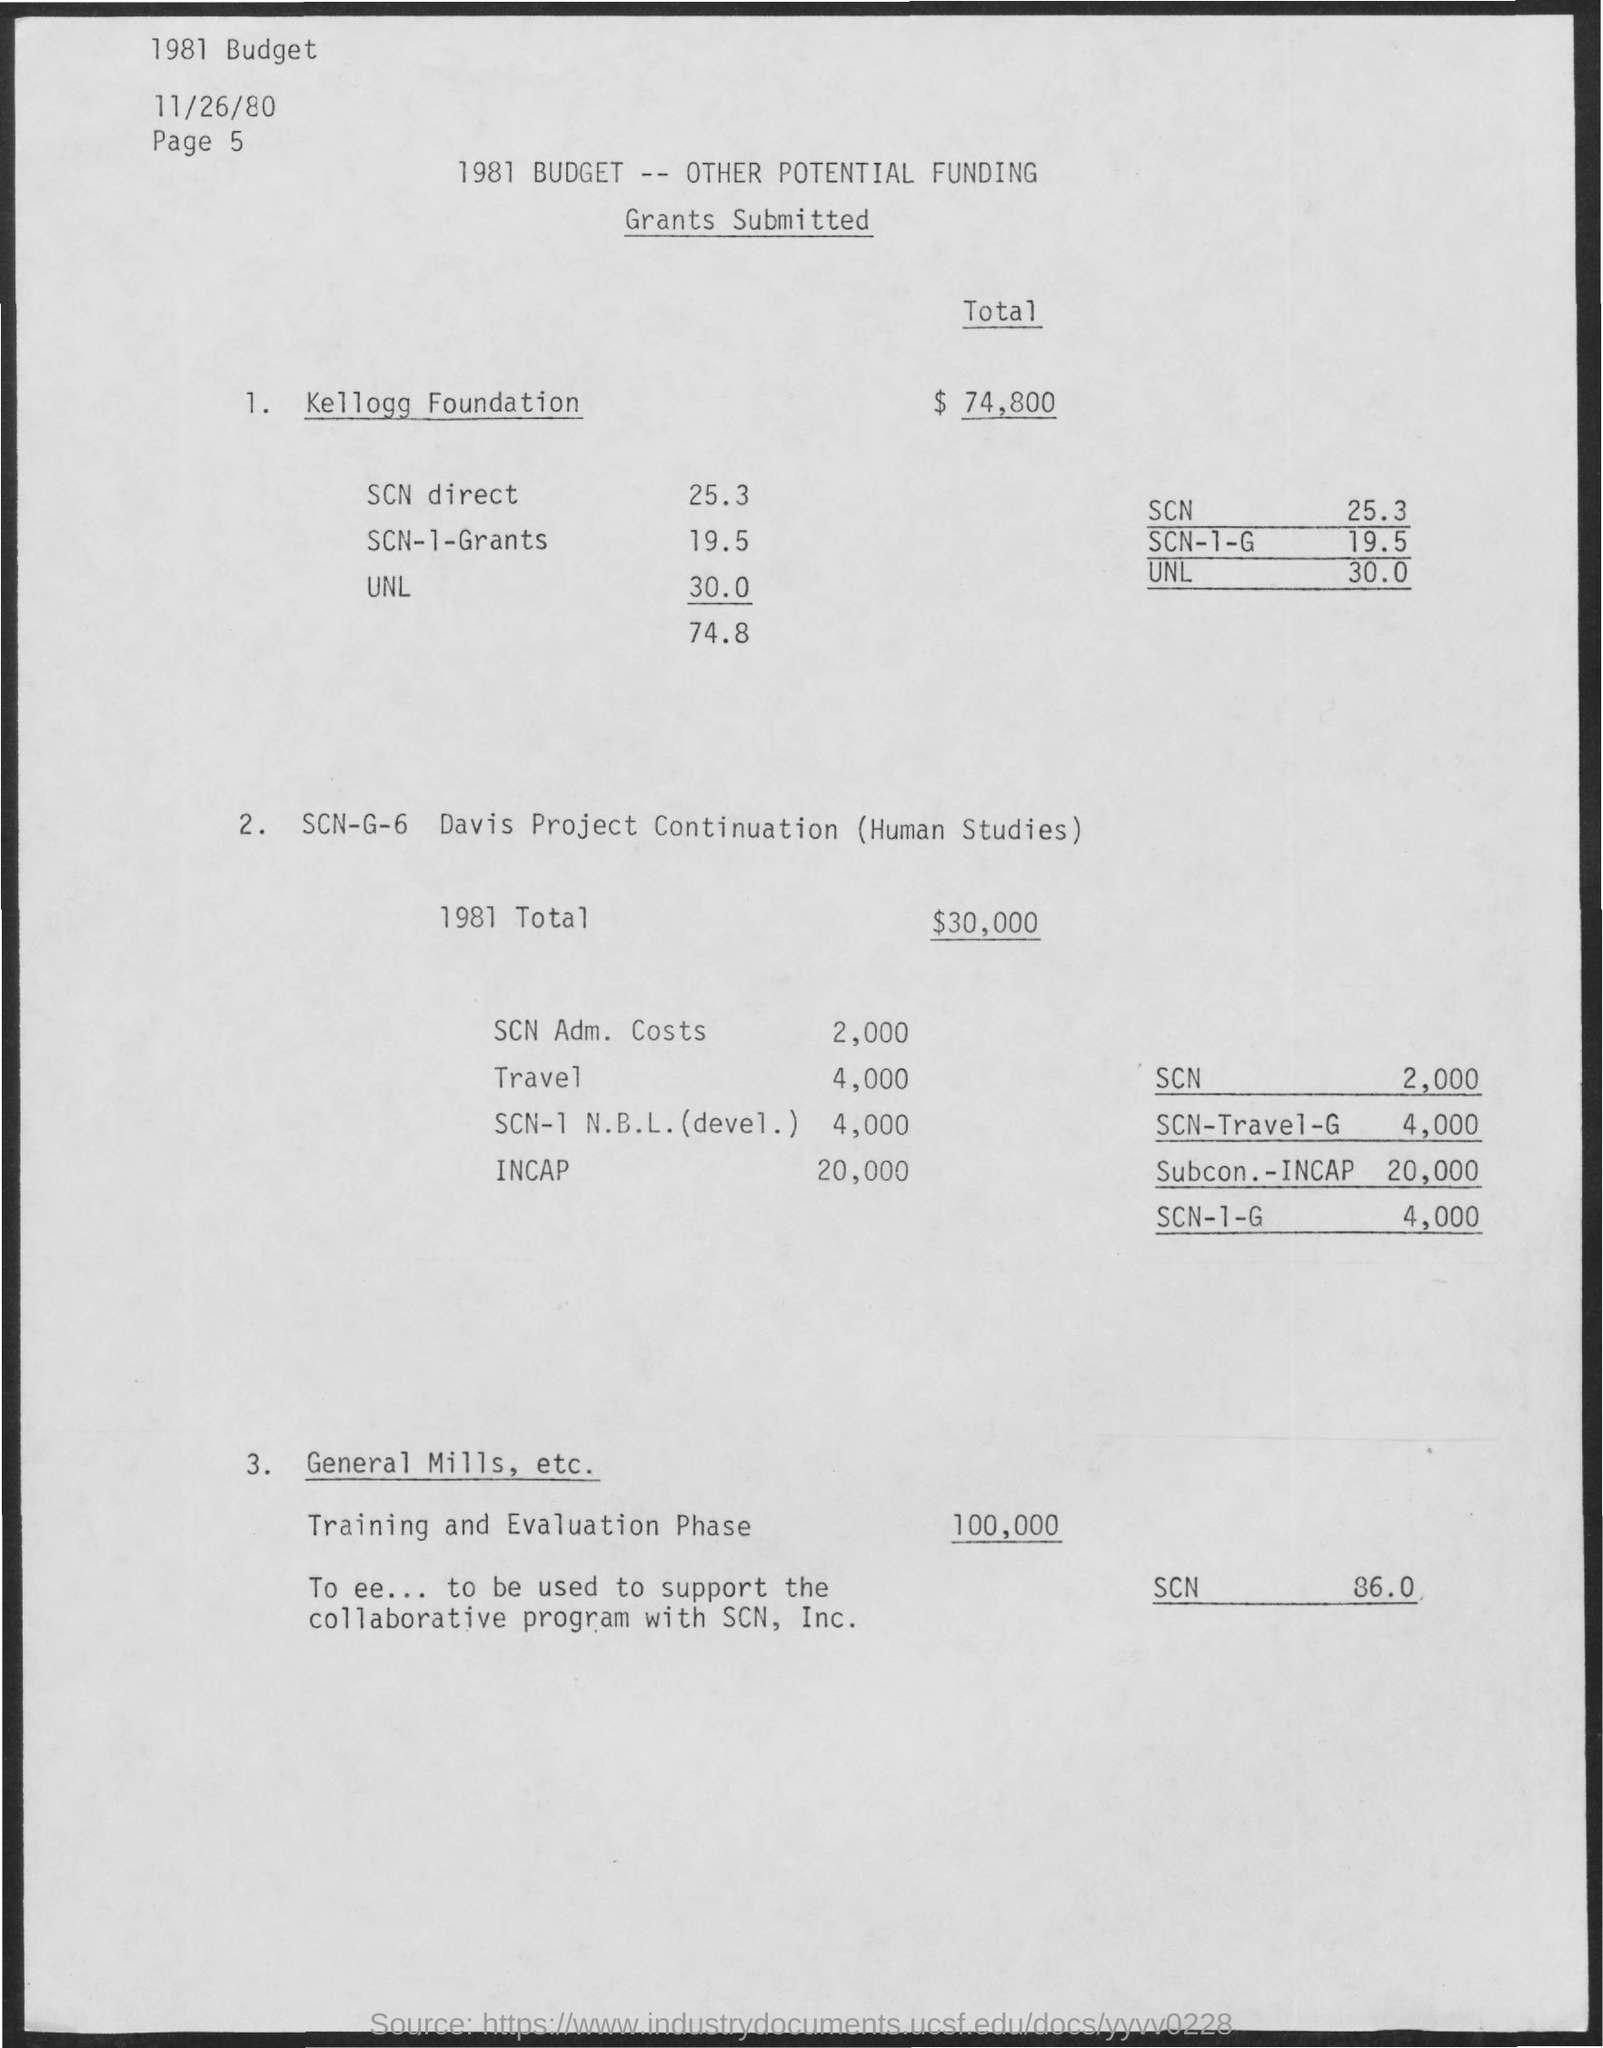What can you tell me about the funding for Human Studies under SCN-G-6 Davis Project Continuation? The SCN-G-6 Davis Project Continuation for Human Studies has a total budget of $30,000. This includes administrative costs ($2,000), travel expenses ($4,000), SCN-I-N.B.L. development ($4,000), and a substantial portion allocated to INCAP ($20,000). The document seems to list budgetary components but doesn't provide specific details about the studies themselves. 